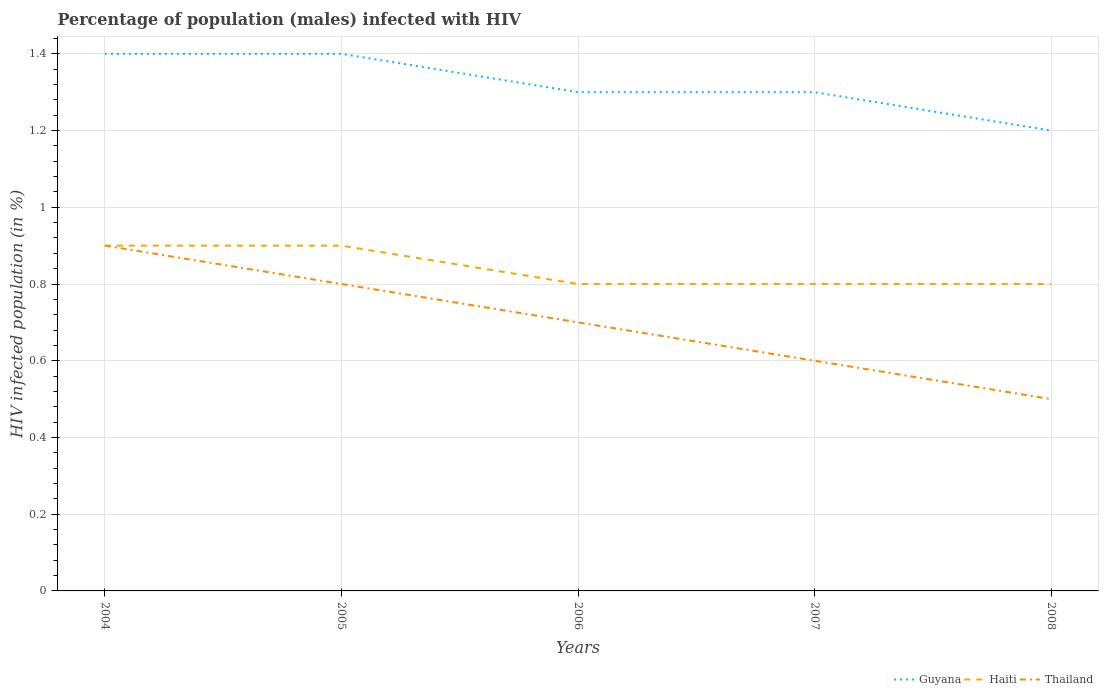How many different coloured lines are there?
Give a very brief answer. 3. Does the line corresponding to Guyana intersect with the line corresponding to Haiti?
Provide a short and direct response. No. In which year was the percentage of HIV infected male population in Thailand maximum?
Provide a succinct answer. 2008. What is the total percentage of HIV infected male population in Thailand in the graph?
Your response must be concise. 0.2. What is the difference between the highest and the second highest percentage of HIV infected male population in Guyana?
Give a very brief answer. 0.2. Is the percentage of HIV infected male population in Thailand strictly greater than the percentage of HIV infected male population in Haiti over the years?
Make the answer very short. No. How many years are there in the graph?
Offer a terse response. 5. Are the values on the major ticks of Y-axis written in scientific E-notation?
Offer a terse response. No. Does the graph contain grids?
Keep it short and to the point. Yes. How many legend labels are there?
Offer a very short reply. 3. What is the title of the graph?
Provide a succinct answer. Percentage of population (males) infected with HIV. What is the label or title of the Y-axis?
Offer a terse response. HIV infected population (in %). What is the HIV infected population (in %) of Haiti in 2004?
Provide a short and direct response. 0.9. What is the HIV infected population (in %) in Guyana in 2005?
Offer a very short reply. 1.4. What is the HIV infected population (in %) of Thailand in 2005?
Provide a succinct answer. 0.8. What is the HIV infected population (in %) in Guyana in 2006?
Provide a short and direct response. 1.3. What is the HIV infected population (in %) in Haiti in 2006?
Your answer should be compact. 0.8. What is the HIV infected population (in %) of Thailand in 2006?
Keep it short and to the point. 0.7. What is the HIV infected population (in %) in Haiti in 2007?
Your answer should be very brief. 0.8. What is the HIV infected population (in %) in Haiti in 2008?
Give a very brief answer. 0.8. Across all years, what is the maximum HIV infected population (in %) in Guyana?
Give a very brief answer. 1.4. What is the total HIV infected population (in %) in Guyana in the graph?
Provide a succinct answer. 6.6. What is the difference between the HIV infected population (in %) in Guyana in 2004 and that in 2005?
Your answer should be compact. 0. What is the difference between the HIV infected population (in %) of Haiti in 2004 and that in 2005?
Keep it short and to the point. 0. What is the difference between the HIV infected population (in %) of Thailand in 2004 and that in 2005?
Your response must be concise. 0.1. What is the difference between the HIV infected population (in %) of Thailand in 2004 and that in 2006?
Your answer should be compact. 0.2. What is the difference between the HIV infected population (in %) in Guyana in 2004 and that in 2007?
Your answer should be compact. 0.1. What is the difference between the HIV infected population (in %) of Haiti in 2004 and that in 2007?
Your answer should be compact. 0.1. What is the difference between the HIV infected population (in %) in Haiti in 2004 and that in 2008?
Your response must be concise. 0.1. What is the difference between the HIV infected population (in %) of Haiti in 2005 and that in 2006?
Your answer should be very brief. 0.1. What is the difference between the HIV infected population (in %) in Thailand in 2005 and that in 2006?
Provide a short and direct response. 0.1. What is the difference between the HIV infected population (in %) of Haiti in 2005 and that in 2007?
Your response must be concise. 0.1. What is the difference between the HIV infected population (in %) of Guyana in 2005 and that in 2008?
Make the answer very short. 0.2. What is the difference between the HIV infected population (in %) in Haiti in 2005 and that in 2008?
Ensure brevity in your answer.  0.1. What is the difference between the HIV infected population (in %) in Guyana in 2006 and that in 2007?
Your response must be concise. 0. What is the difference between the HIV infected population (in %) of Haiti in 2006 and that in 2007?
Offer a very short reply. 0. What is the difference between the HIV infected population (in %) in Thailand in 2006 and that in 2007?
Provide a short and direct response. 0.1. What is the difference between the HIV infected population (in %) in Haiti in 2006 and that in 2008?
Ensure brevity in your answer.  0. What is the difference between the HIV infected population (in %) of Thailand in 2007 and that in 2008?
Your answer should be compact. 0.1. What is the difference between the HIV infected population (in %) in Guyana in 2004 and the HIV infected population (in %) in Thailand in 2005?
Provide a succinct answer. 0.6. What is the difference between the HIV infected population (in %) of Haiti in 2004 and the HIV infected population (in %) of Thailand in 2005?
Provide a succinct answer. 0.1. What is the difference between the HIV infected population (in %) of Guyana in 2004 and the HIV infected population (in %) of Haiti in 2006?
Ensure brevity in your answer.  0.6. What is the difference between the HIV infected population (in %) in Guyana in 2004 and the HIV infected population (in %) in Thailand in 2007?
Offer a terse response. 0.8. What is the difference between the HIV infected population (in %) in Haiti in 2004 and the HIV infected population (in %) in Thailand in 2007?
Ensure brevity in your answer.  0.3. What is the difference between the HIV infected population (in %) of Guyana in 2004 and the HIV infected population (in %) of Thailand in 2008?
Your answer should be very brief. 0.9. What is the difference between the HIV infected population (in %) in Guyana in 2005 and the HIV infected population (in %) in Haiti in 2007?
Keep it short and to the point. 0.6. What is the difference between the HIV infected population (in %) of Guyana in 2005 and the HIV infected population (in %) of Haiti in 2008?
Offer a very short reply. 0.6. What is the difference between the HIV infected population (in %) in Guyana in 2005 and the HIV infected population (in %) in Thailand in 2008?
Your response must be concise. 0.9. What is the difference between the HIV infected population (in %) of Haiti in 2006 and the HIV infected population (in %) of Thailand in 2007?
Ensure brevity in your answer.  0.2. What is the difference between the HIV infected population (in %) in Guyana in 2006 and the HIV infected population (in %) in Haiti in 2008?
Provide a short and direct response. 0.5. What is the difference between the HIV infected population (in %) in Haiti in 2006 and the HIV infected population (in %) in Thailand in 2008?
Provide a succinct answer. 0.3. What is the difference between the HIV infected population (in %) of Guyana in 2007 and the HIV infected population (in %) of Haiti in 2008?
Your answer should be compact. 0.5. What is the difference between the HIV infected population (in %) in Guyana in 2007 and the HIV infected population (in %) in Thailand in 2008?
Your response must be concise. 0.8. What is the average HIV infected population (in %) of Guyana per year?
Your answer should be compact. 1.32. What is the average HIV infected population (in %) of Haiti per year?
Offer a very short reply. 0.84. In the year 2004, what is the difference between the HIV infected population (in %) of Guyana and HIV infected population (in %) of Haiti?
Offer a very short reply. 0.5. In the year 2004, what is the difference between the HIV infected population (in %) in Haiti and HIV infected population (in %) in Thailand?
Your response must be concise. 0. In the year 2005, what is the difference between the HIV infected population (in %) in Haiti and HIV infected population (in %) in Thailand?
Make the answer very short. 0.1. In the year 2006, what is the difference between the HIV infected population (in %) in Guyana and HIV infected population (in %) in Haiti?
Offer a terse response. 0.5. In the year 2007, what is the difference between the HIV infected population (in %) in Guyana and HIV infected population (in %) in Haiti?
Keep it short and to the point. 0.5. In the year 2007, what is the difference between the HIV infected population (in %) of Haiti and HIV infected population (in %) of Thailand?
Give a very brief answer. 0.2. In the year 2008, what is the difference between the HIV infected population (in %) in Guyana and HIV infected population (in %) in Thailand?
Your answer should be very brief. 0.7. What is the ratio of the HIV infected population (in %) of Haiti in 2004 to that in 2005?
Ensure brevity in your answer.  1. What is the ratio of the HIV infected population (in %) in Guyana in 2004 to that in 2006?
Ensure brevity in your answer.  1.08. What is the ratio of the HIV infected population (in %) of Haiti in 2004 to that in 2006?
Provide a succinct answer. 1.12. What is the ratio of the HIV infected population (in %) in Guyana in 2004 to that in 2007?
Ensure brevity in your answer.  1.08. What is the ratio of the HIV infected population (in %) in Guyana in 2004 to that in 2008?
Provide a short and direct response. 1.17. What is the ratio of the HIV infected population (in %) in Haiti in 2004 to that in 2008?
Offer a terse response. 1.12. What is the ratio of the HIV infected population (in %) in Guyana in 2005 to that in 2007?
Provide a succinct answer. 1.08. What is the ratio of the HIV infected population (in %) in Thailand in 2005 to that in 2007?
Ensure brevity in your answer.  1.33. What is the ratio of the HIV infected population (in %) in Guyana in 2005 to that in 2008?
Your answer should be very brief. 1.17. What is the ratio of the HIV infected population (in %) in Thailand in 2005 to that in 2008?
Make the answer very short. 1.6. What is the ratio of the HIV infected population (in %) in Guyana in 2006 to that in 2007?
Your answer should be very brief. 1. What is the ratio of the HIV infected population (in %) in Haiti in 2006 to that in 2007?
Your answer should be very brief. 1. What is the ratio of the HIV infected population (in %) of Guyana in 2006 to that in 2008?
Provide a short and direct response. 1.08. What is the ratio of the HIV infected population (in %) in Thailand in 2006 to that in 2008?
Your response must be concise. 1.4. What is the ratio of the HIV infected population (in %) of Guyana in 2007 to that in 2008?
Offer a terse response. 1.08. What is the ratio of the HIV infected population (in %) in Haiti in 2007 to that in 2008?
Provide a succinct answer. 1. What is the difference between the highest and the second highest HIV infected population (in %) in Guyana?
Offer a very short reply. 0. What is the difference between the highest and the second highest HIV infected population (in %) in Thailand?
Provide a short and direct response. 0.1. What is the difference between the highest and the lowest HIV infected population (in %) of Haiti?
Offer a very short reply. 0.1. What is the difference between the highest and the lowest HIV infected population (in %) of Thailand?
Ensure brevity in your answer.  0.4. 